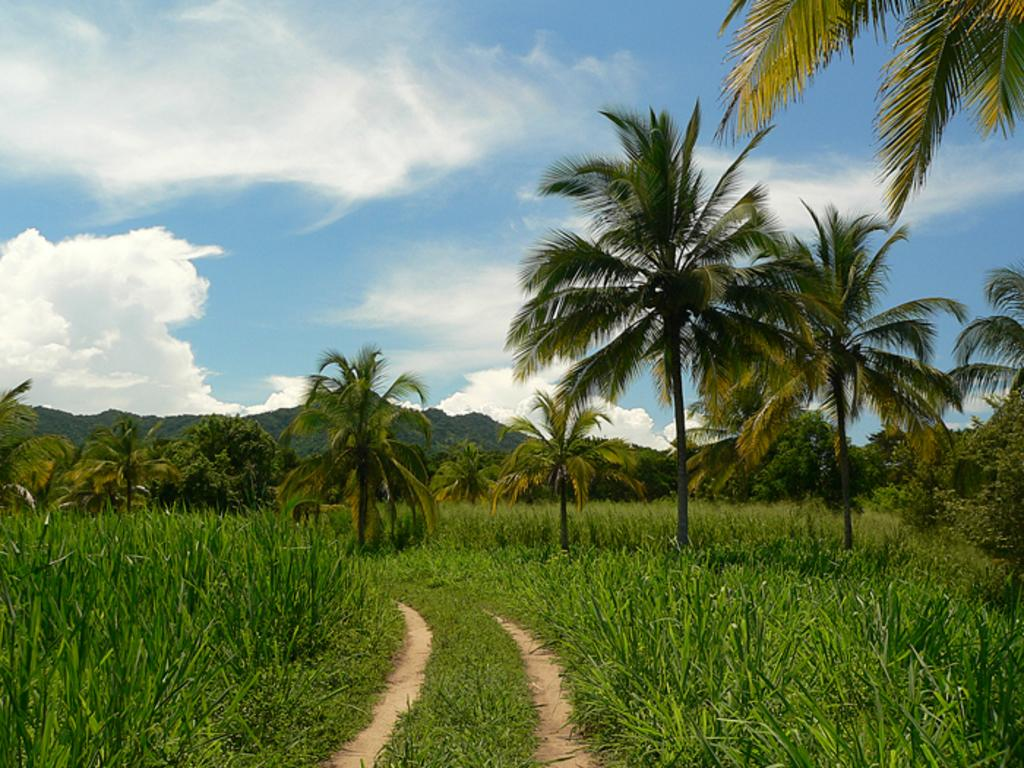What type of vegetation can be seen in the image? There are trees in the image. What geographical features are present in the image? There are hills in the image. What type of ground cover is visible at the bottom of the image? There is grass at the bottom of the image. What can be seen in the sky at the top of the image? There are clouds in the sky at the top of the image. What sense is being stimulated by the orange in the image? There is no orange present in the image, so no sense is being stimulated by it. 